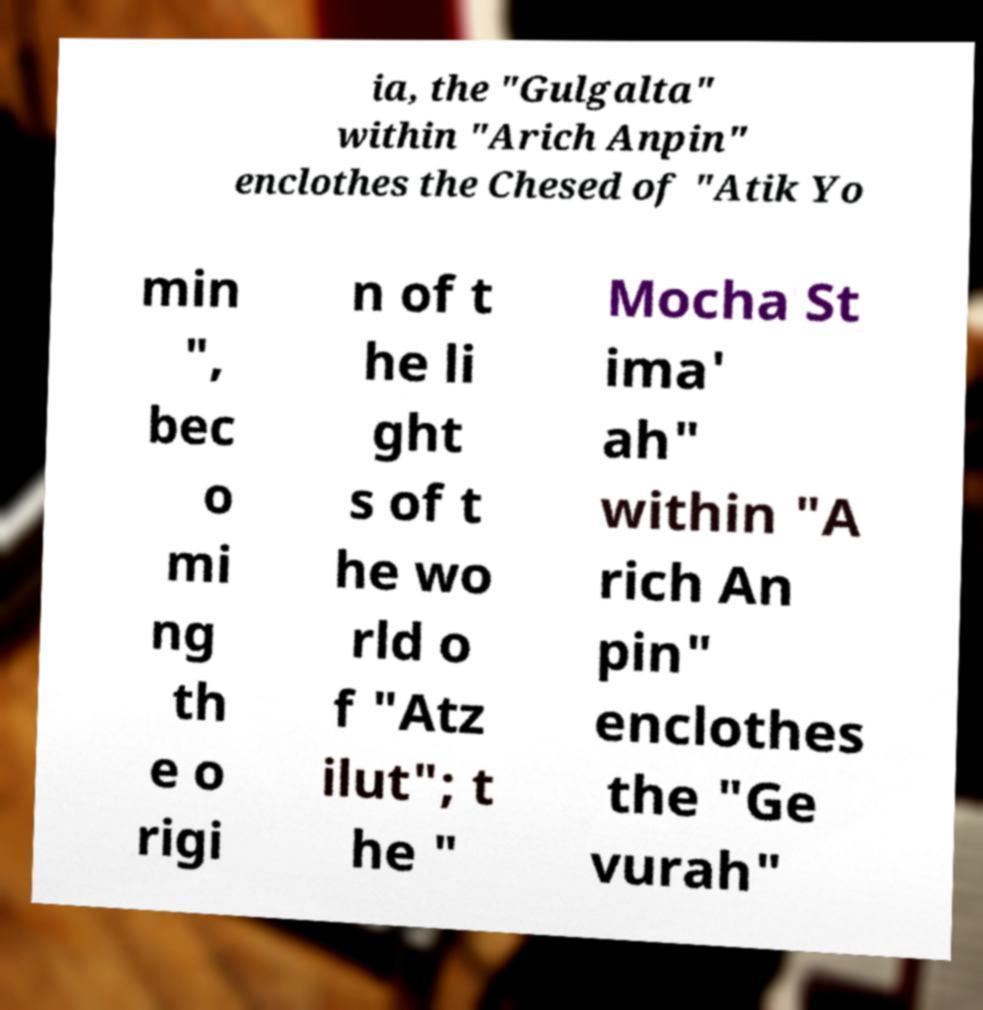I need the written content from this picture converted into text. Can you do that? ia, the "Gulgalta" within "Arich Anpin" enclothes the Chesed of "Atik Yo min ", bec o mi ng th e o rigi n of t he li ght s of t he wo rld o f "Atz ilut"; t he " Mocha St ima' ah" within "A rich An pin" enclothes the "Ge vurah" 